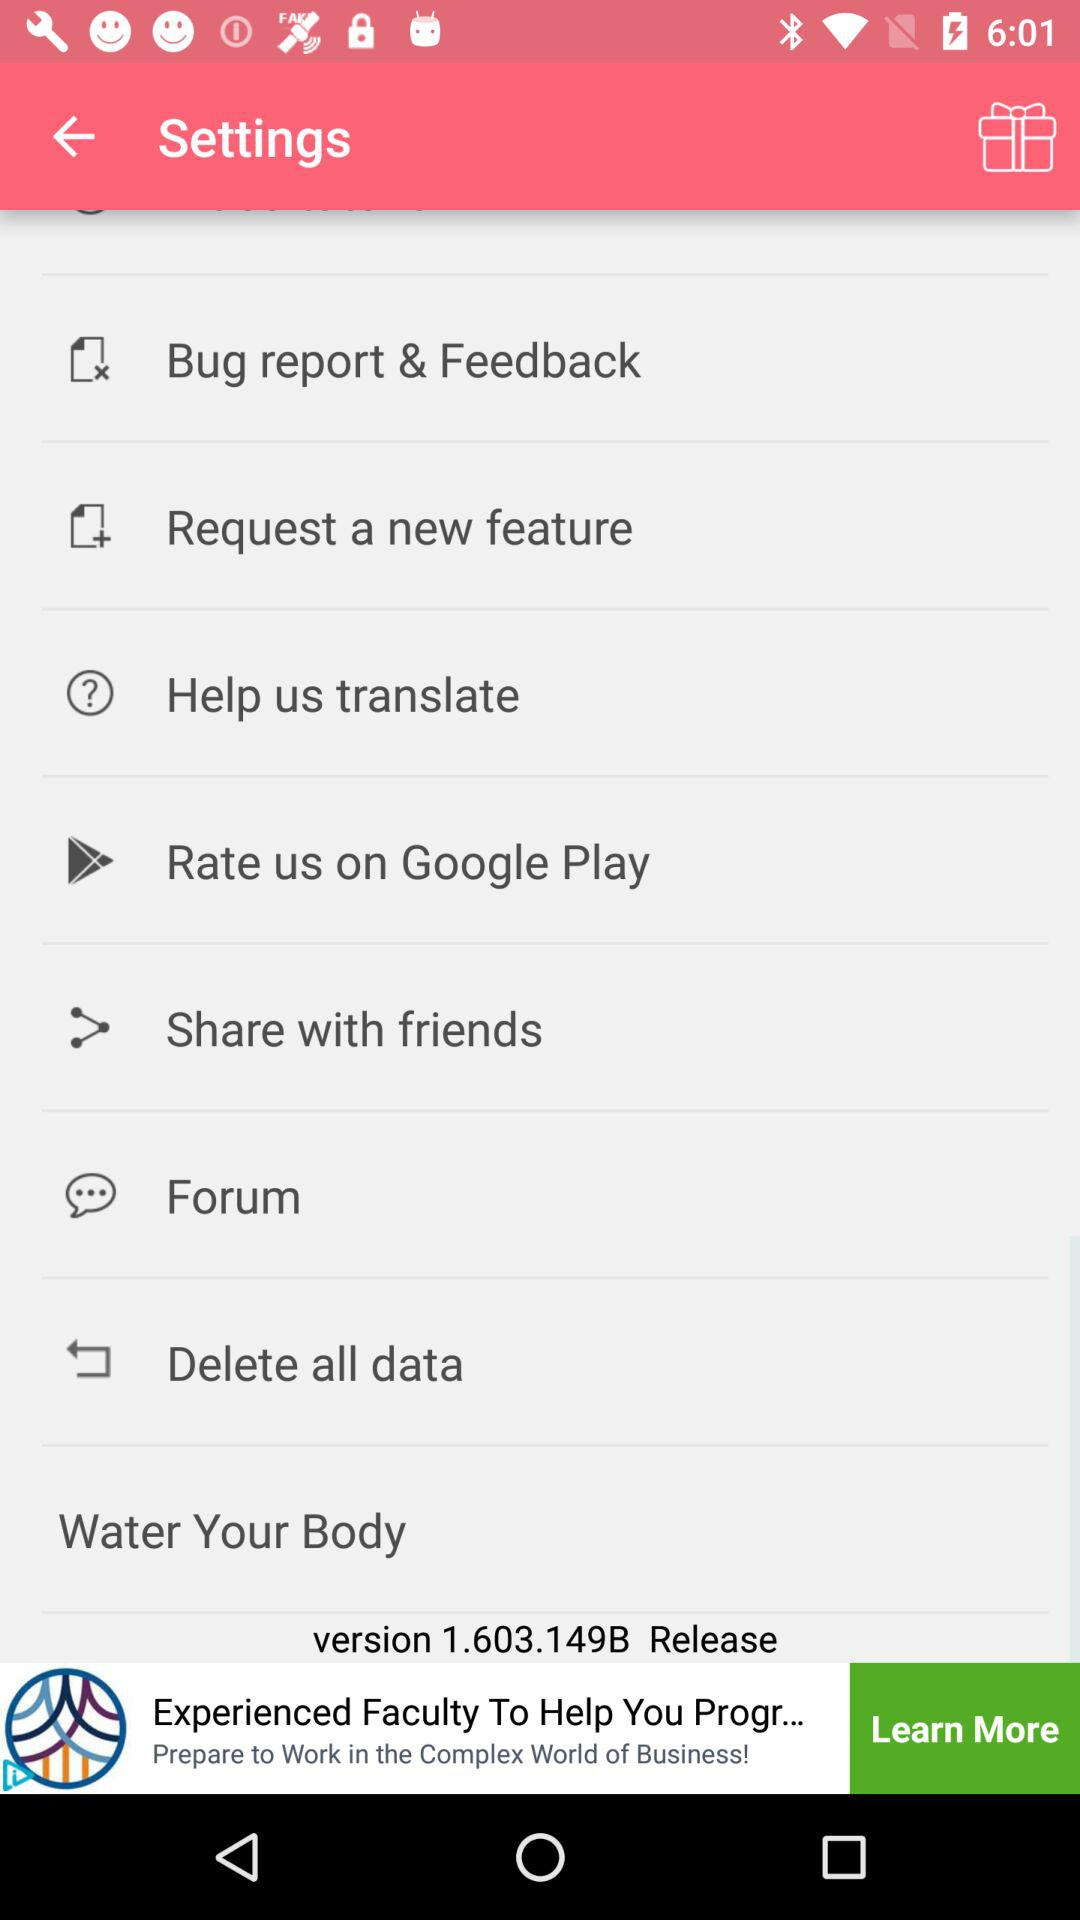How many items are in the settings menu?
Answer the question using a single word or phrase. 8 